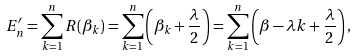<formula> <loc_0><loc_0><loc_500><loc_500>E ^ { \prime } _ { n } = \sum _ { k = 1 } ^ { n } R ( \beta _ { k } ) = \sum _ { k = 1 } ^ { n } \left ( \beta _ { k } + \frac { \lambda } { 2 } \right ) = \sum _ { k = 1 } ^ { n } \left ( \beta - \lambda k + \frac { \lambda } { 2 } \right ) ,</formula> 